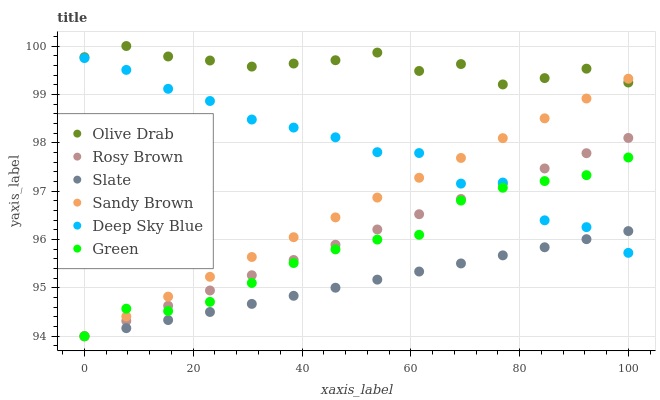Does Slate have the minimum area under the curve?
Answer yes or no. Yes. Does Olive Drab have the maximum area under the curve?
Answer yes or no. Yes. Does Rosy Brown have the minimum area under the curve?
Answer yes or no. No. Does Rosy Brown have the maximum area under the curve?
Answer yes or no. No. Is Slate the smoothest?
Answer yes or no. Yes. Is Deep Sky Blue the roughest?
Answer yes or no. Yes. Is Rosy Brown the smoothest?
Answer yes or no. No. Is Rosy Brown the roughest?
Answer yes or no. No. Does Slate have the lowest value?
Answer yes or no. Yes. Does Deep Sky Blue have the lowest value?
Answer yes or no. No. Does Olive Drab have the highest value?
Answer yes or no. Yes. Does Rosy Brown have the highest value?
Answer yes or no. No. Is Slate less than Olive Drab?
Answer yes or no. Yes. Is Olive Drab greater than Green?
Answer yes or no. Yes. Does Rosy Brown intersect Slate?
Answer yes or no. Yes. Is Rosy Brown less than Slate?
Answer yes or no. No. Is Rosy Brown greater than Slate?
Answer yes or no. No. Does Slate intersect Olive Drab?
Answer yes or no. No. 